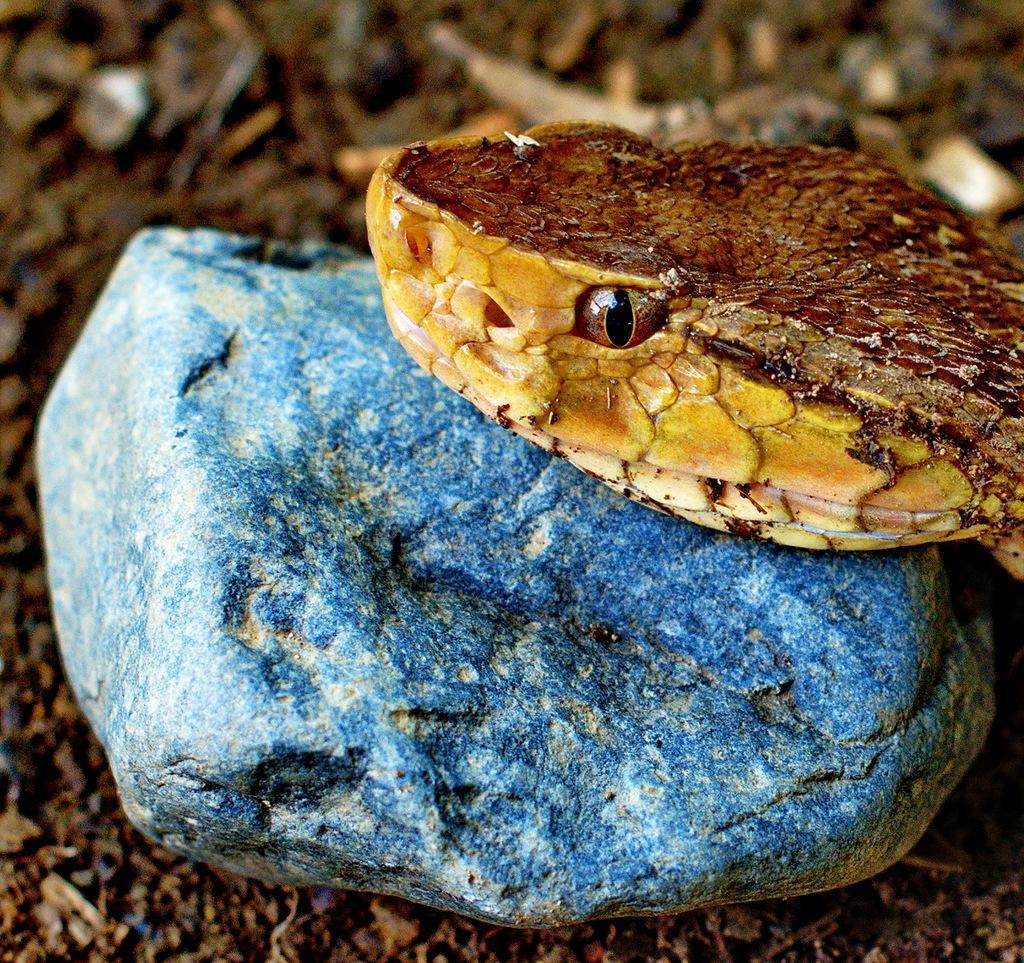Could you give a brief overview of what you see in this image? In this image a snake head is visible. It is on a rock which is on the land. 